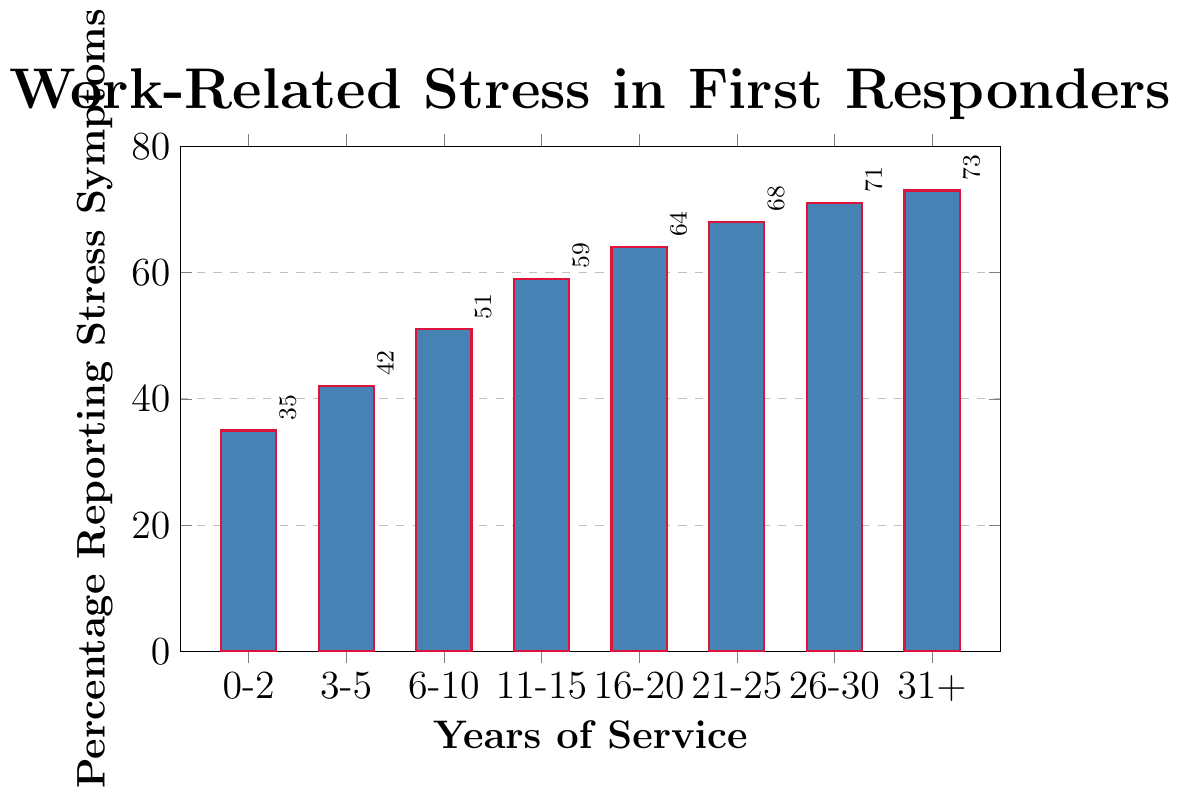What percentage of first responders with 11-15 years of service report work-related stress symptoms? Identify the bar corresponding to '11-15 years of service'. The height of this bar represents 59%.
Answer: 59 Which group has the highest percentage of first responders reporting work-related stress symptoms? Find the bar with the greatest height, which corresponds to '31+ years of service'. This bar represents 73%.
Answer: 31+ years of service How does the percentage of stress symptoms in the 0-2 years group compare to the 16-20 years group? Compare the heights of the bars for '0-2 years of service' (35%) and '16-20 years of service' (64%).
Answer: Less in 0-2 years group What's the average percentage of first responders reporting stress symptoms for groups with 6 or more years of service? Sum the percentages for groups '6-10', '11-15', '16-20', '21-25', '26-30', '31+' and divide by the number of these groups: (51 + 59 + 64 + 68 + 71 + 73) / 6.
Answer: 64.33 What is the gap in stress symptoms reporting between the shortest and tallest bars? Subtract the percentage of the shortest bar ('0-2 years', 35%) from the percentage of the tallest bar ('31+ years', 73%).
Answer: 38 How does the percentage reporting stress symptoms change from 6-10 to 11-15 years of service? Find the difference in percentages between '6-10 years of service' (51%) and '11-15 years of service' (59%).
Answer: Increase by 8% Compare the stress symptoms percentages of first responders with 21-25 years and 26-30 years of service. Compare the heights of the bars for '21-25 years of service' (68%) and '26-30 years of service' (71%).
Answer: Less in 21-25 years Is there a trend in stress symptoms reporting as years of service increase? Observe the overall pattern of how the bar heights change as years of service increase. They consistently increase, indicating a rising trend.
Answer: Increasing trend What is the percentage point difference between the groups with 3-5 years and 16-20 years of service? Subtract the percentage for '3-5 years' (42%) from the percentage for '16-20 years' (64%).
Answer: 22 What is the color of the bars representing the stress symptoms for first responders? Identify the color used to fill the bars. The bars are filled with blue color.
Answer: Blue 